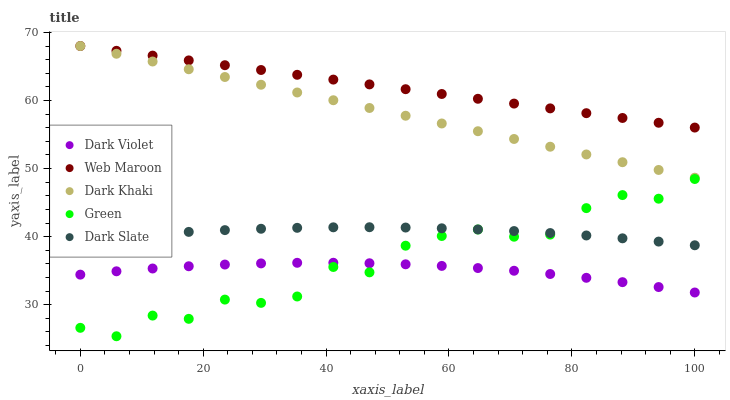Does Dark Violet have the minimum area under the curve?
Answer yes or no. Yes. Does Web Maroon have the maximum area under the curve?
Answer yes or no. Yes. Does Green have the minimum area under the curve?
Answer yes or no. No. Does Green have the maximum area under the curve?
Answer yes or no. No. Is Web Maroon the smoothest?
Answer yes or no. Yes. Is Green the roughest?
Answer yes or no. Yes. Is Green the smoothest?
Answer yes or no. No. Is Web Maroon the roughest?
Answer yes or no. No. Does Green have the lowest value?
Answer yes or no. Yes. Does Web Maroon have the lowest value?
Answer yes or no. No. Does Web Maroon have the highest value?
Answer yes or no. Yes. Does Green have the highest value?
Answer yes or no. No. Is Dark Slate less than Dark Khaki?
Answer yes or no. Yes. Is Web Maroon greater than Green?
Answer yes or no. Yes. Does Dark Violet intersect Green?
Answer yes or no. Yes. Is Dark Violet less than Green?
Answer yes or no. No. Is Dark Violet greater than Green?
Answer yes or no. No. Does Dark Slate intersect Dark Khaki?
Answer yes or no. No. 